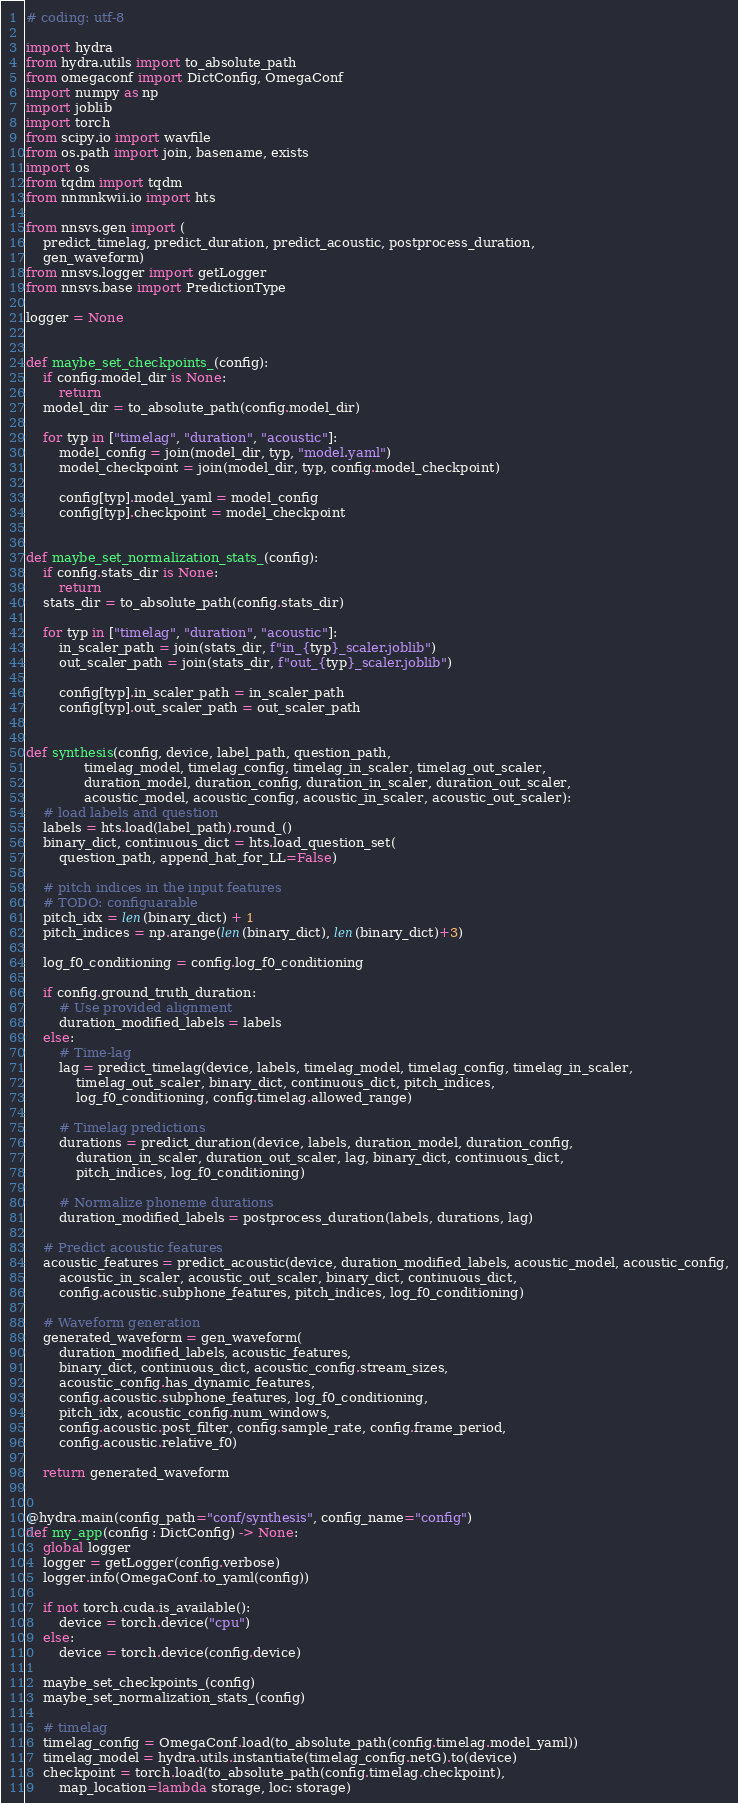<code> <loc_0><loc_0><loc_500><loc_500><_Python_># coding: utf-8

import hydra
from hydra.utils import to_absolute_path
from omegaconf import DictConfig, OmegaConf
import numpy as np
import joblib
import torch
from scipy.io import wavfile
from os.path import join, basename, exists
import os
from tqdm import tqdm
from nnmnkwii.io import hts

from nnsvs.gen import (
    predict_timelag, predict_duration, predict_acoustic, postprocess_duration,
    gen_waveform)
from nnsvs.logger import getLogger
from nnsvs.base import PredictionType

logger = None


def maybe_set_checkpoints_(config):
    if config.model_dir is None:
        return
    model_dir = to_absolute_path(config.model_dir)

    for typ in ["timelag", "duration", "acoustic"]:
        model_config = join(model_dir, typ, "model.yaml")
        model_checkpoint = join(model_dir, typ, config.model_checkpoint)

        config[typ].model_yaml = model_config
        config[typ].checkpoint = model_checkpoint


def maybe_set_normalization_stats_(config):
    if config.stats_dir is None:
        return
    stats_dir = to_absolute_path(config.stats_dir)

    for typ in ["timelag", "duration", "acoustic"]:
        in_scaler_path = join(stats_dir, f"in_{typ}_scaler.joblib")
        out_scaler_path = join(stats_dir, f"out_{typ}_scaler.joblib")

        config[typ].in_scaler_path = in_scaler_path
        config[typ].out_scaler_path = out_scaler_path


def synthesis(config, device, label_path, question_path,
              timelag_model, timelag_config, timelag_in_scaler, timelag_out_scaler,
              duration_model, duration_config, duration_in_scaler, duration_out_scaler,
              acoustic_model, acoustic_config, acoustic_in_scaler, acoustic_out_scaler):
    # load labels and question
    labels = hts.load(label_path).round_()
    binary_dict, continuous_dict = hts.load_question_set(
        question_path, append_hat_for_LL=False)

    # pitch indices in the input features
    # TODO: configuarable
    pitch_idx = len(binary_dict) + 1
    pitch_indices = np.arange(len(binary_dict), len(binary_dict)+3)

    log_f0_conditioning = config.log_f0_conditioning

    if config.ground_truth_duration:
        # Use provided alignment
        duration_modified_labels = labels
    else:
        # Time-lag
        lag = predict_timelag(device, labels, timelag_model, timelag_config, timelag_in_scaler,
            timelag_out_scaler, binary_dict, continuous_dict, pitch_indices,
            log_f0_conditioning, config.timelag.allowed_range)

        # Timelag predictions
        durations = predict_duration(device, labels, duration_model, duration_config,
            duration_in_scaler, duration_out_scaler, lag, binary_dict, continuous_dict,
            pitch_indices, log_f0_conditioning)

        # Normalize phoneme durations
        duration_modified_labels = postprocess_duration(labels, durations, lag)

    # Predict acoustic features
    acoustic_features = predict_acoustic(device, duration_modified_labels, acoustic_model, acoustic_config,
        acoustic_in_scaler, acoustic_out_scaler, binary_dict, continuous_dict,
        config.acoustic.subphone_features, pitch_indices, log_f0_conditioning)

    # Waveform generation
    generated_waveform = gen_waveform(
        duration_modified_labels, acoustic_features,
        binary_dict, continuous_dict, acoustic_config.stream_sizes,
        acoustic_config.has_dynamic_features,
        config.acoustic.subphone_features, log_f0_conditioning,
        pitch_idx, acoustic_config.num_windows,
        config.acoustic.post_filter, config.sample_rate, config.frame_period,
        config.acoustic.relative_f0)

    return generated_waveform


@hydra.main(config_path="conf/synthesis", config_name="config")
def my_app(config : DictConfig) -> None:
    global logger
    logger = getLogger(config.verbose)
    logger.info(OmegaConf.to_yaml(config))

    if not torch.cuda.is_available():
        device = torch.device("cpu")
    else:
        device = torch.device(config.device)

    maybe_set_checkpoints_(config)
    maybe_set_normalization_stats_(config)

    # timelag
    timelag_config = OmegaConf.load(to_absolute_path(config.timelag.model_yaml))
    timelag_model = hydra.utils.instantiate(timelag_config.netG).to(device)
    checkpoint = torch.load(to_absolute_path(config.timelag.checkpoint),
        map_location=lambda storage, loc: storage)</code> 